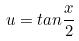<formula> <loc_0><loc_0><loc_500><loc_500>u = t a n \frac { x } { 2 }</formula> 